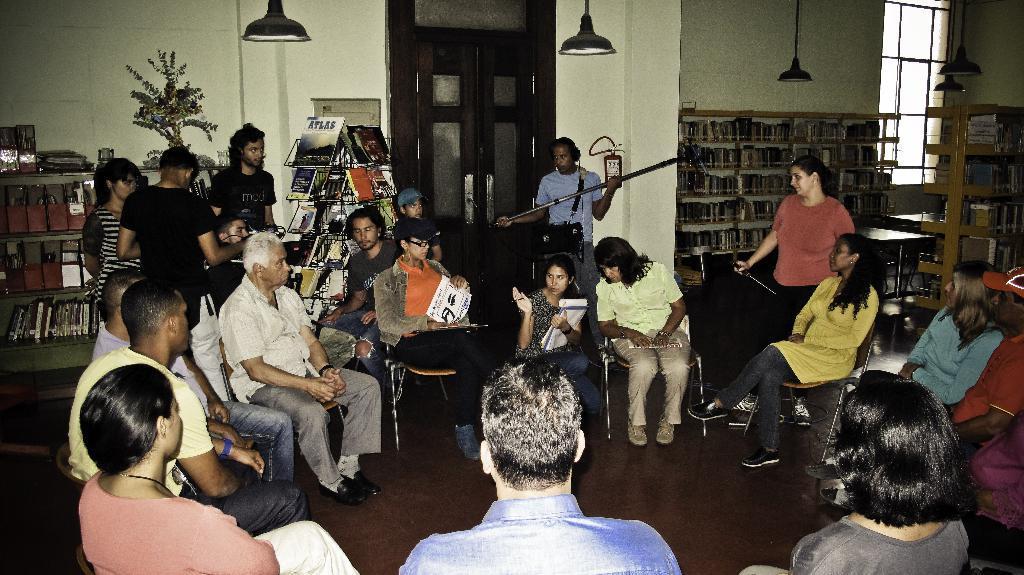Can you describe this image briefly? In this picture we can see a group of people sitting on the chair and holding objects in their hands. There are few books in a book stand. We can see some books in the shelves. There is a plant, a door and a fire extinguisher on the wall. 